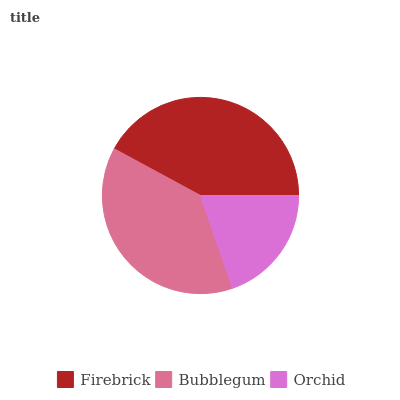Is Orchid the minimum?
Answer yes or no. Yes. Is Firebrick the maximum?
Answer yes or no. Yes. Is Bubblegum the minimum?
Answer yes or no. No. Is Bubblegum the maximum?
Answer yes or no. No. Is Firebrick greater than Bubblegum?
Answer yes or no. Yes. Is Bubblegum less than Firebrick?
Answer yes or no. Yes. Is Bubblegum greater than Firebrick?
Answer yes or no. No. Is Firebrick less than Bubblegum?
Answer yes or no. No. Is Bubblegum the high median?
Answer yes or no. Yes. Is Bubblegum the low median?
Answer yes or no. Yes. Is Firebrick the high median?
Answer yes or no. No. Is Orchid the low median?
Answer yes or no. No. 